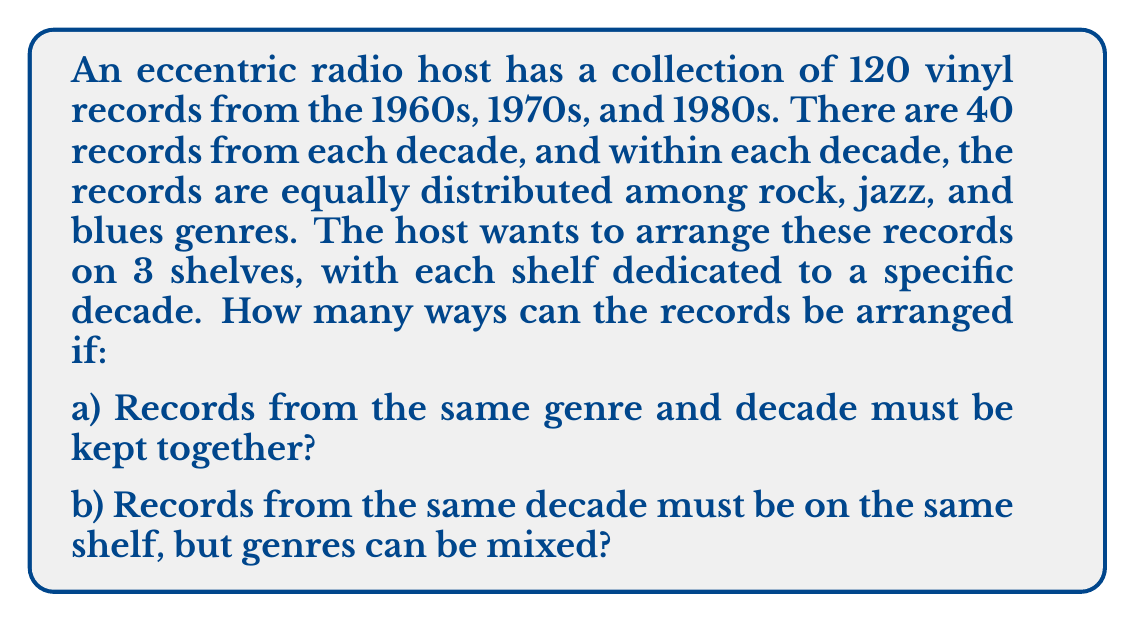Could you help me with this problem? Let's break this down step by step:

a) When records from the same genre and decade must be kept together:

1) First, we need to arrange the decades on the 3 shelves. This can be done in $3! = 6$ ways.

2) For each decade, we have 3 genres (rock, jazz, blues). These can be arranged in $3! = 6$ ways on each shelf.

3) Within each genre of each decade, we have 40/3 ≈ 13 records (assuming we round down). These can be arranged in $13!$ ways.

4) Using the multiplication principle, the total number of arrangements is:

   $$ 6 \times (6 \times 13! \times 13! \times 13!)^3 $$

b) When records from the same decade must be on the same shelf, but genres can be mixed:

1) We still have $3! = 6$ ways to arrange the decades on the shelves.

2) For each decade/shelf, we now have 40 records that can be arranged in any order. This can be done in $40!$ ways for each shelf.

3) Using the multiplication principle, the total number of arrangements is:

   $$ 6 \times 40! \times 40! \times 40! $$
Answer: a) $6 \times (6 \times 13! \times 13! \times 13!)^3$
b) $6 \times 40! \times 40! \times 40!$ 